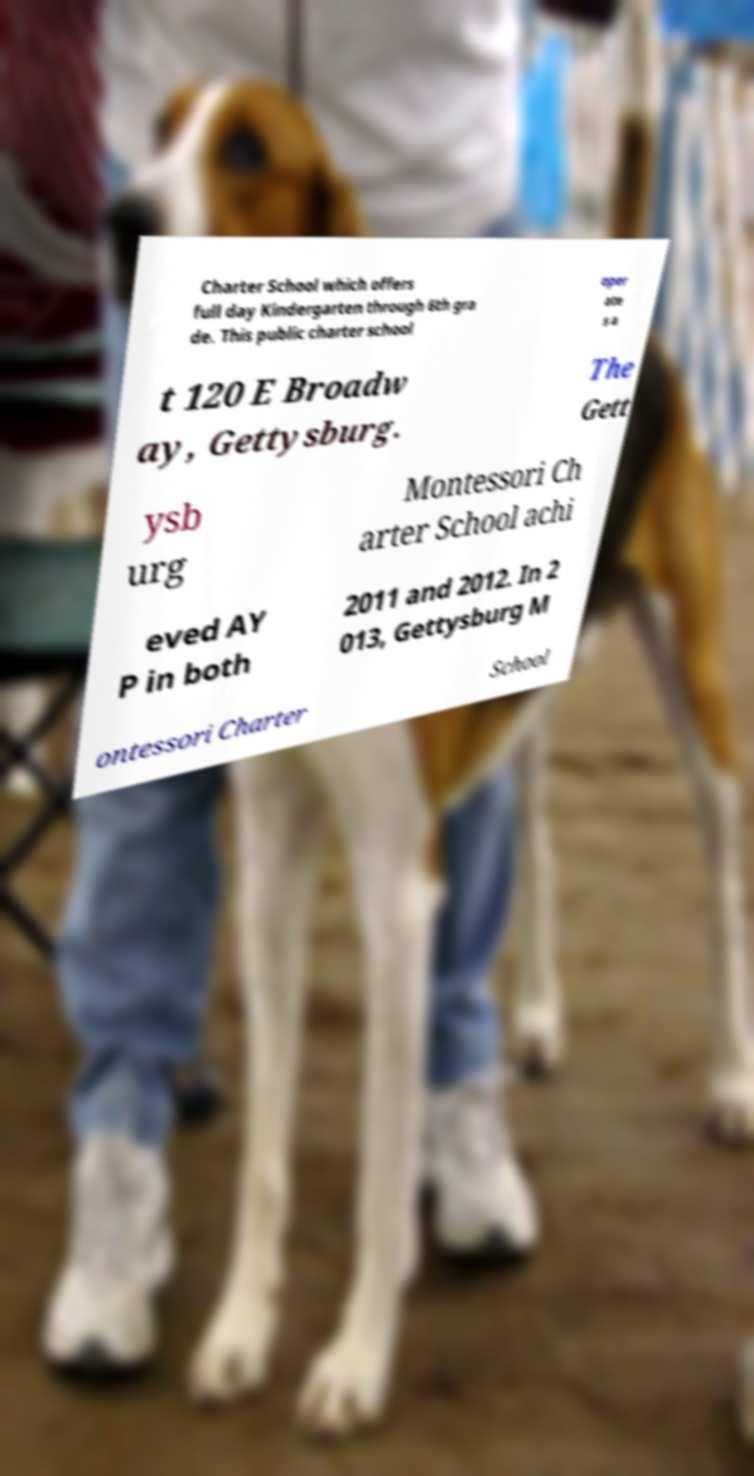Please identify and transcribe the text found in this image. Charter School which offers full day Kindergarten through 6th gra de. This public charter school oper ate s a t 120 E Broadw ay, Gettysburg. The Gett ysb urg Montessori Ch arter School achi eved AY P in both 2011 and 2012. In 2 013, Gettysburg M ontessori Charter School 